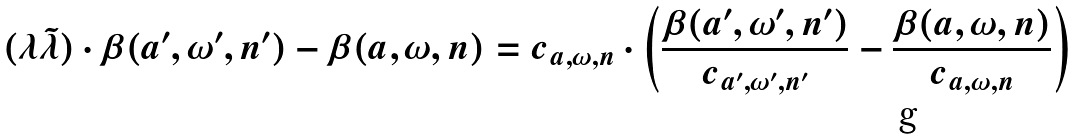<formula> <loc_0><loc_0><loc_500><loc_500>( \lambda \tilde { \lambda } ) \cdot \beta ( a ^ { \prime } , \omega ^ { \prime } , n ^ { \prime } ) - \beta ( a , \omega , n ) = c _ { a , \omega , n } \cdot \left ( \frac { \beta ( a ^ { \prime } , \omega ^ { \prime } , n ^ { \prime } ) } { c _ { a ^ { \prime } , \omega ^ { \prime } , n ^ { \prime } } } - \frac { \beta ( a , \omega , n ) } { c _ { a , \omega , n } } \right )</formula> 